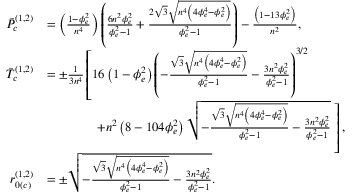Convert formula to latex. <formula><loc_0><loc_0><loc_500><loc_500>\begin{array} { r l } { \ B a r { P } _ { c } ^ { ( 1 , 2 ) } } & { = \left ( \frac { 1 - \phi _ { e } ^ { 2 } } { n ^ { 4 } } \right ) \left ( \frac { 6 n ^ { 2 } \phi _ { e } ^ { 2 } } { \phi _ { e } ^ { 2 } - 1 } + \frac { 2 \sqrt { 3 } \sqrt { n ^ { 4 } \left ( 4 \phi _ { e } ^ { 4 } - \phi _ { e } ^ { 2 } \right ) } } { \phi _ { e } ^ { 2 } - 1 } \right ) - \frac { \left ( 1 - 1 3 \phi _ { e } ^ { 2 } \right ) } { n ^ { 2 } } , } \\ { \ B a r { T } _ { c } ^ { ( 1 , 2 ) } } & { = \pm \frac { 1 } { 3 n ^ { 4 } } \left [ 1 6 \left ( 1 - \phi _ { e } ^ { 2 } \right ) \left ( - \frac { \sqrt { 3 } \sqrt { n ^ { 4 } \left ( 4 \phi _ { e } ^ { 4 } - \phi _ { e } ^ { 2 } \right ) } } { \phi _ { e } ^ { 2 } - 1 } - \frac { 3 n ^ { 2 } \phi _ { e } ^ { 2 } } { \phi _ { e } ^ { 2 } - 1 } \right ) ^ { 3 / 2 } } \\ & { \, + n ^ { 2 } \left ( 8 - 1 0 4 \phi _ { e } ^ { 2 } \right ) \sqrt { - \frac { \sqrt { 3 } \sqrt { n ^ { 4 } \left ( 4 \phi _ { e } ^ { 4 } - \phi _ { e } ^ { 2 } \right ) } } { \phi _ { e } ^ { 2 } - 1 } - \frac { 3 n ^ { 2 } \phi _ { e } ^ { 2 } } { \phi _ { e } ^ { 2 } - 1 } } \, \right ] , } \\ { r _ { 0 ( c ) } ^ { ( 1 , 2 ) } } & { = \pm \sqrt { - \frac { \sqrt { 3 } \sqrt { n ^ { 4 } \left ( 4 \phi _ { e } ^ { 4 } - \phi _ { e } ^ { 2 } \right ) } } { \phi _ { e } ^ { 2 } - 1 } - \frac { 3 n ^ { 2 } \phi _ { e } ^ { 2 } } { \phi _ { e } ^ { 2 } - 1 } } . } \end{array}</formula> 